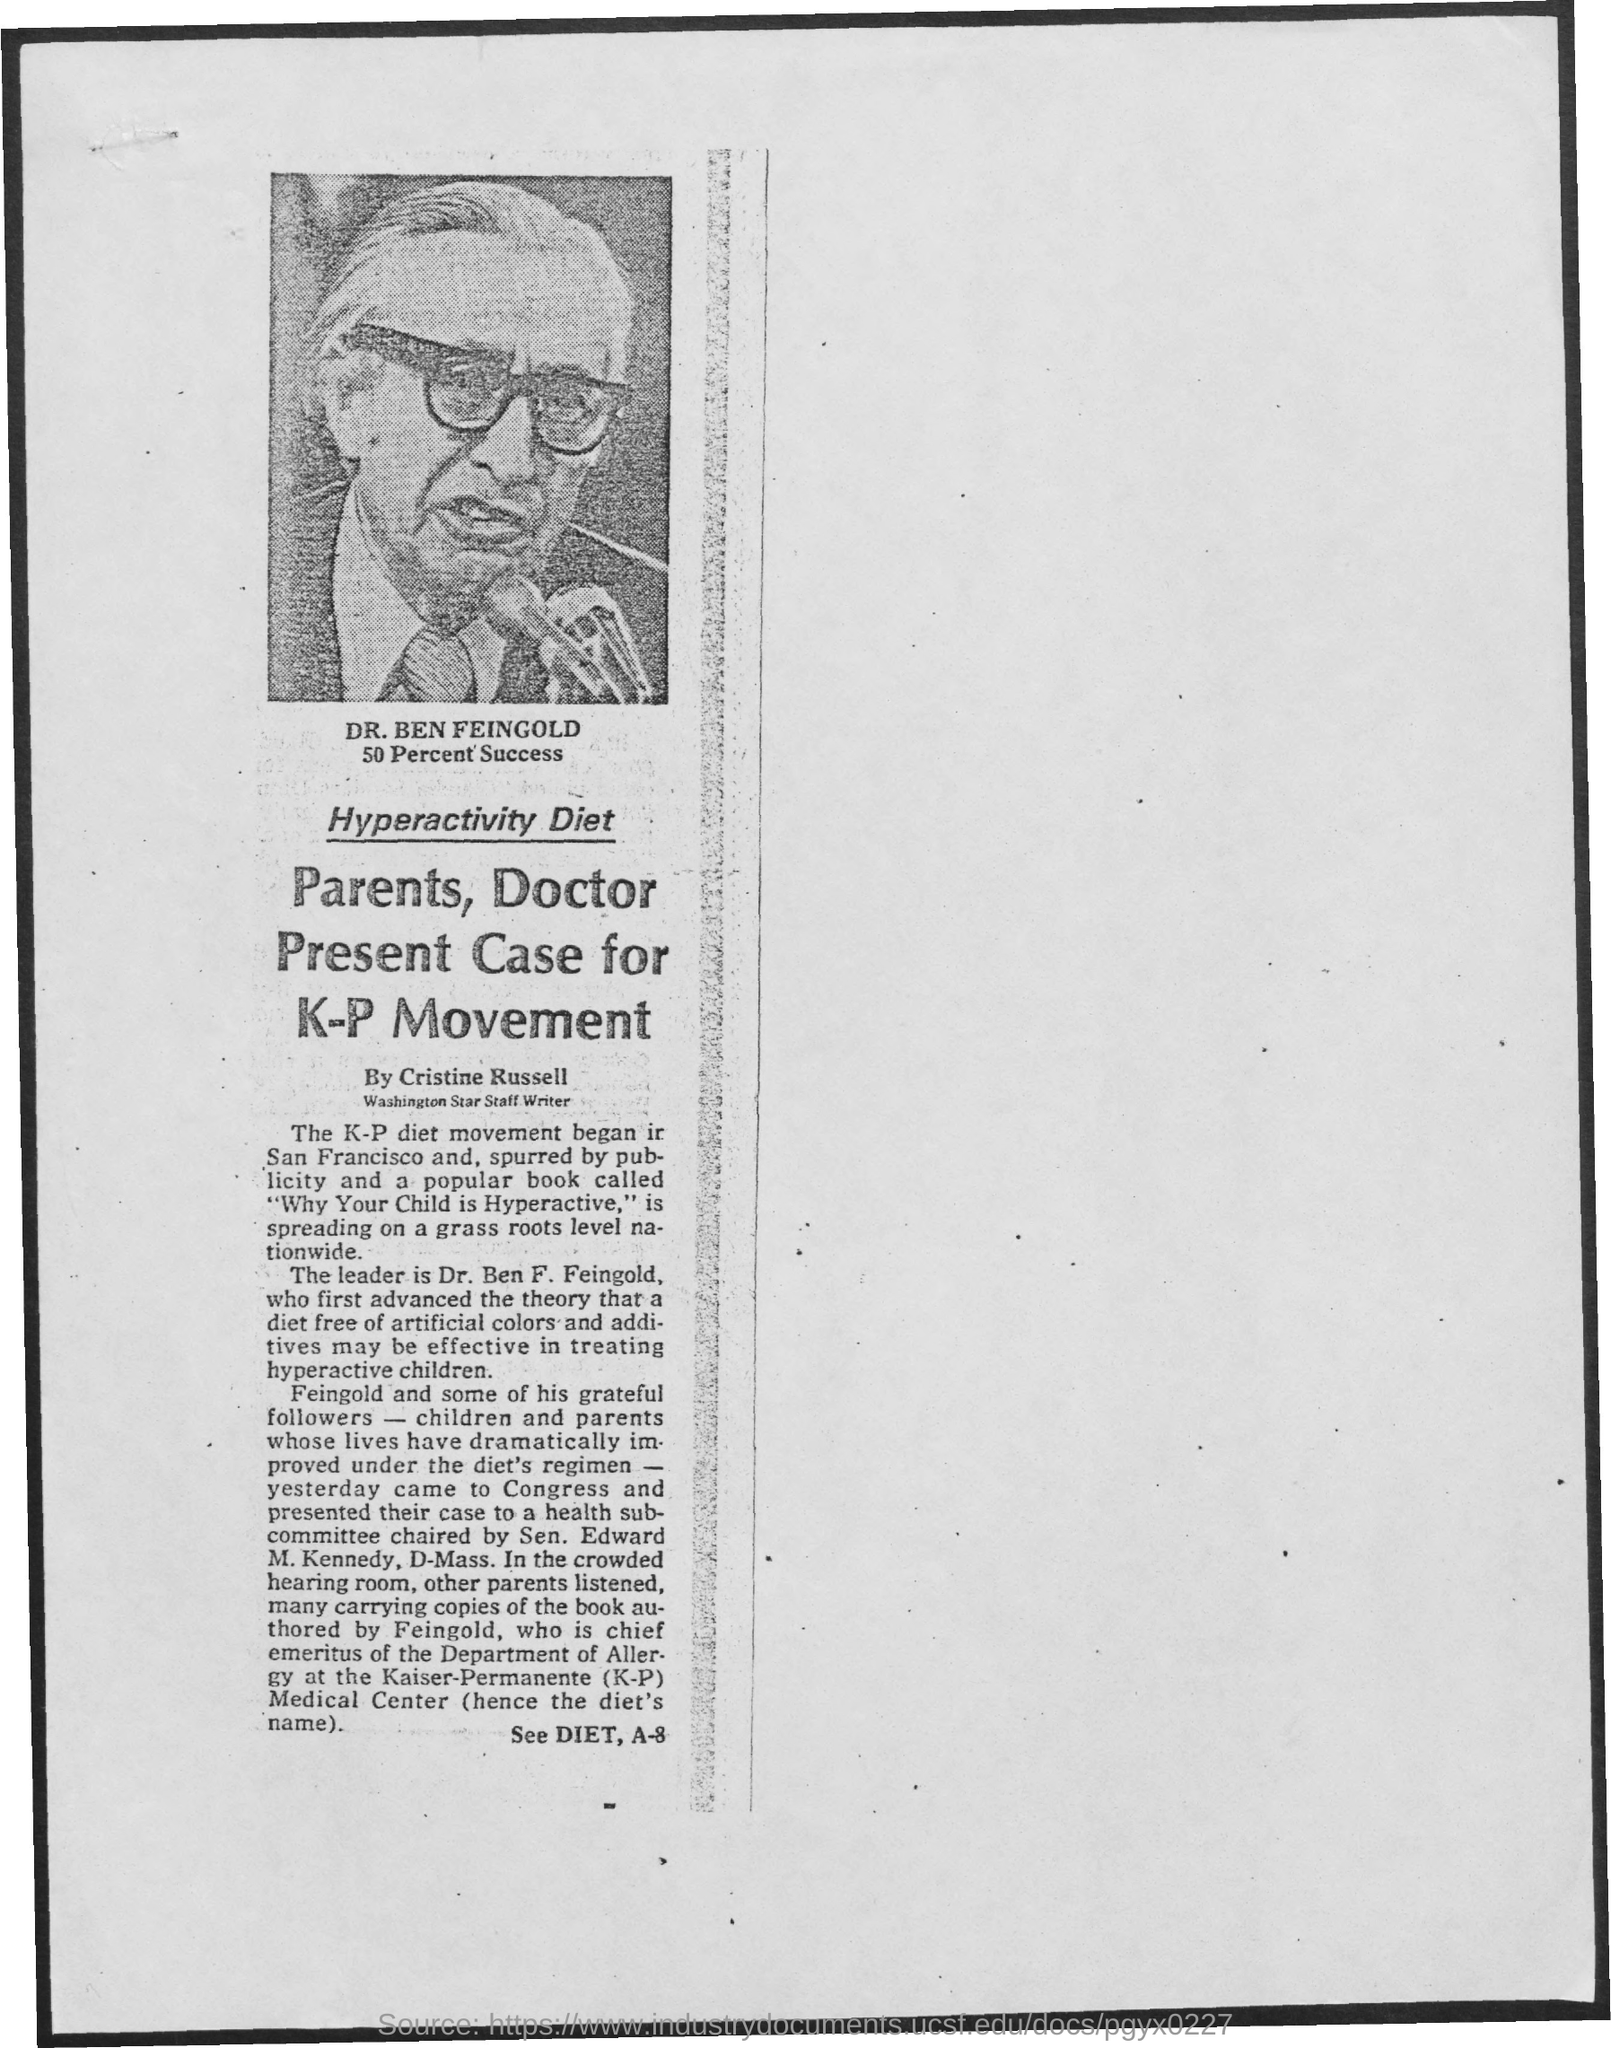Who presents the case for K-P Movement?
Offer a terse response. Parents, doctor. Who has written the article?
Give a very brief answer. Cristine russell. 